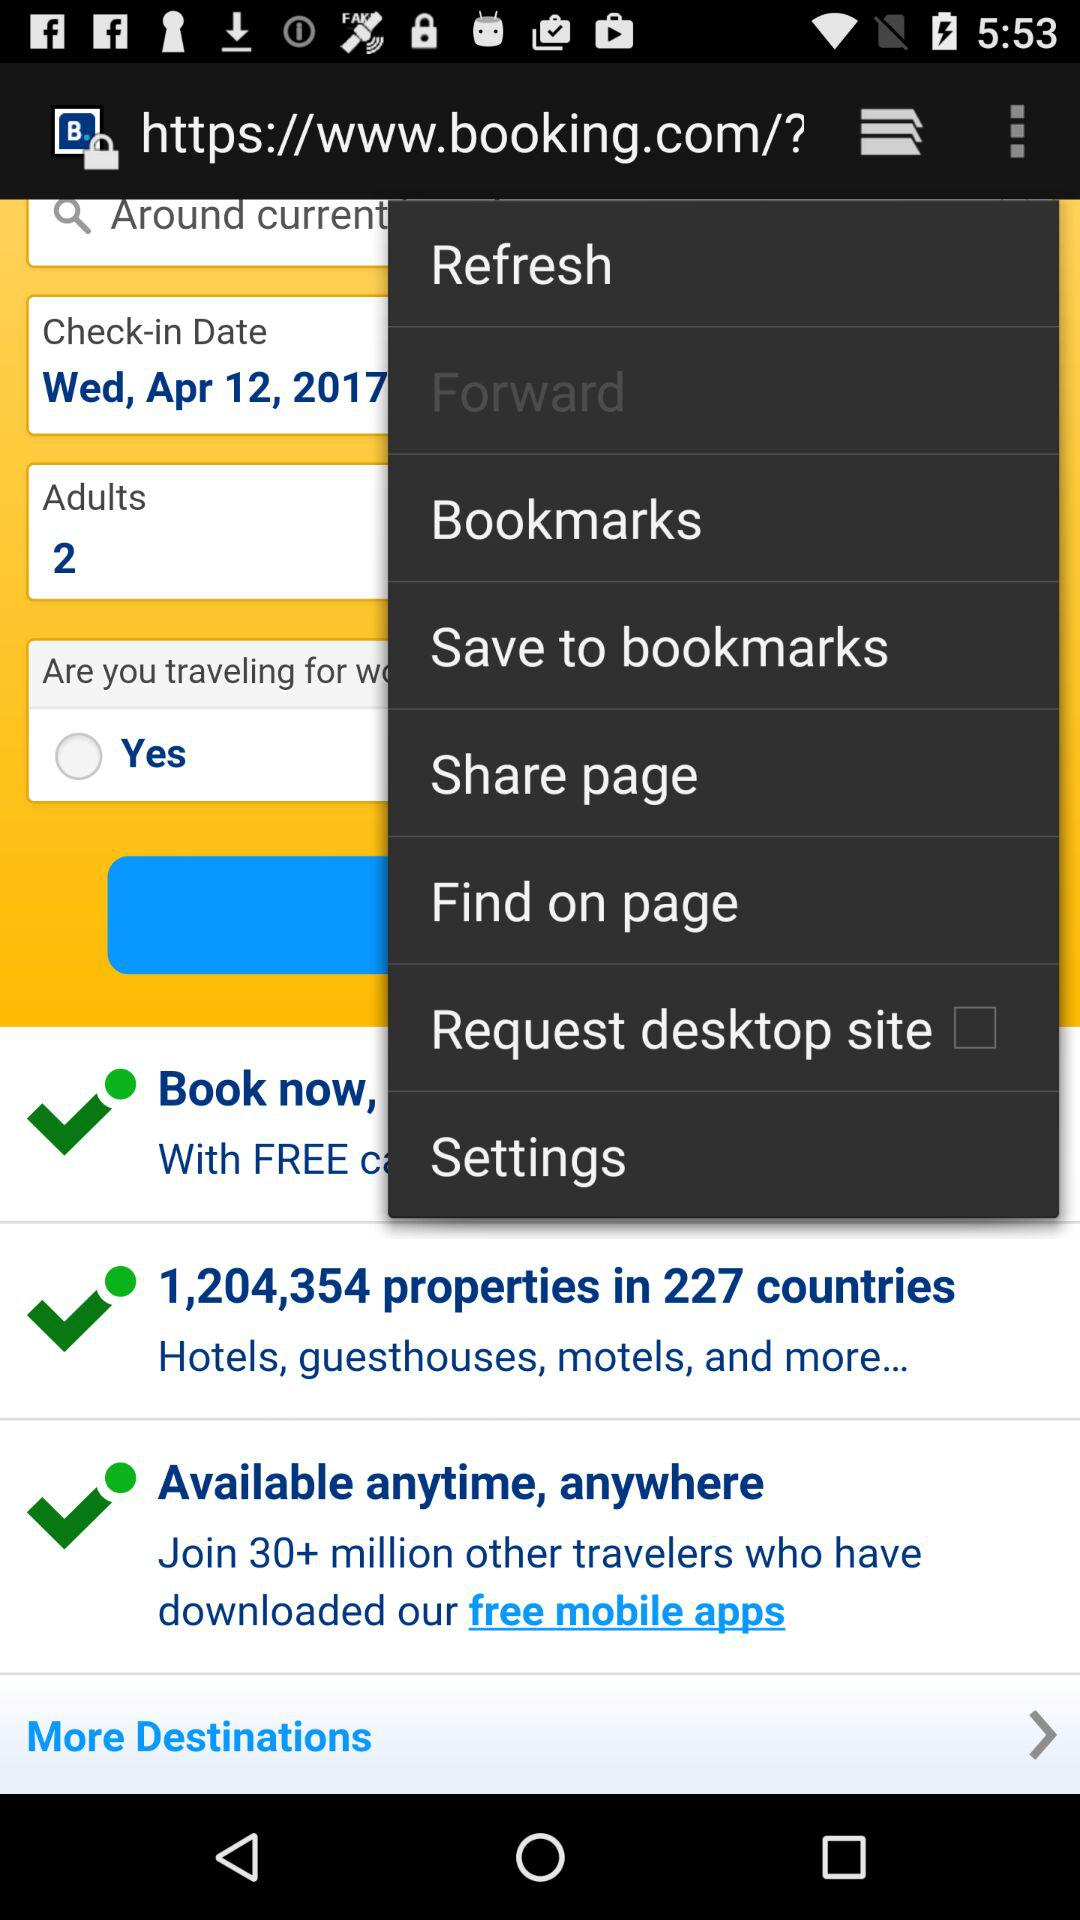What is the check-in date? The check-in date is Wednesday, April 12, 2017. 